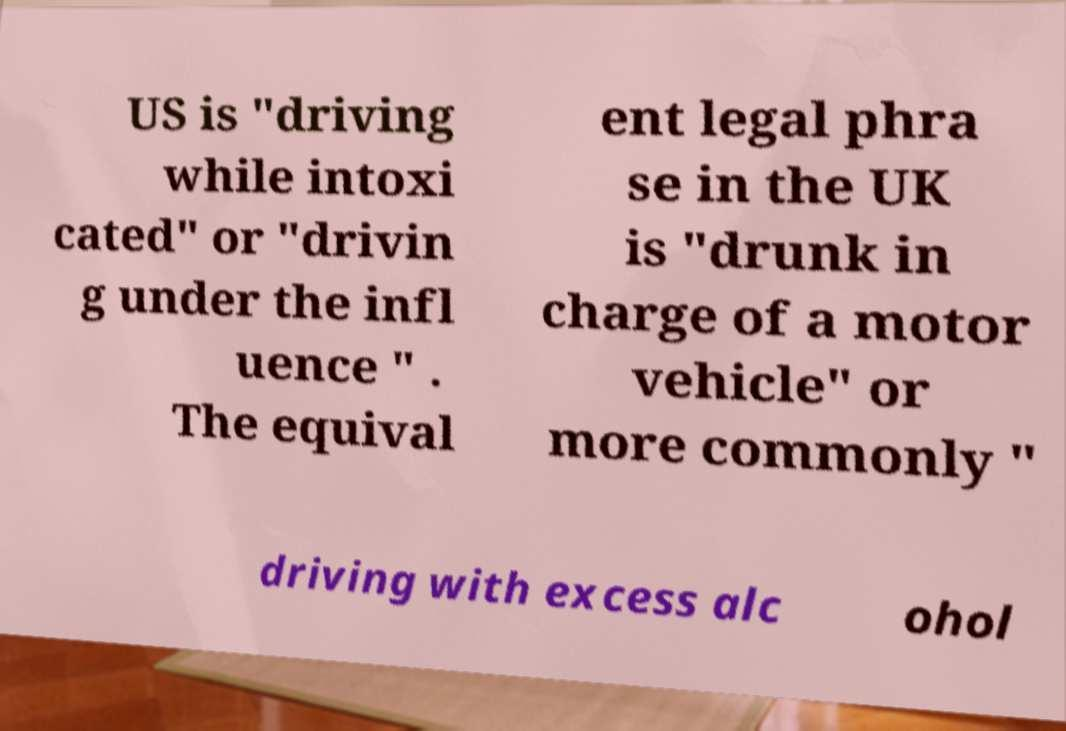Can you read and provide the text displayed in the image?This photo seems to have some interesting text. Can you extract and type it out for me? US is "driving while intoxi cated" or "drivin g under the infl uence " . The equival ent legal phra se in the UK is "drunk in charge of a motor vehicle" or more commonly " driving with excess alc ohol 